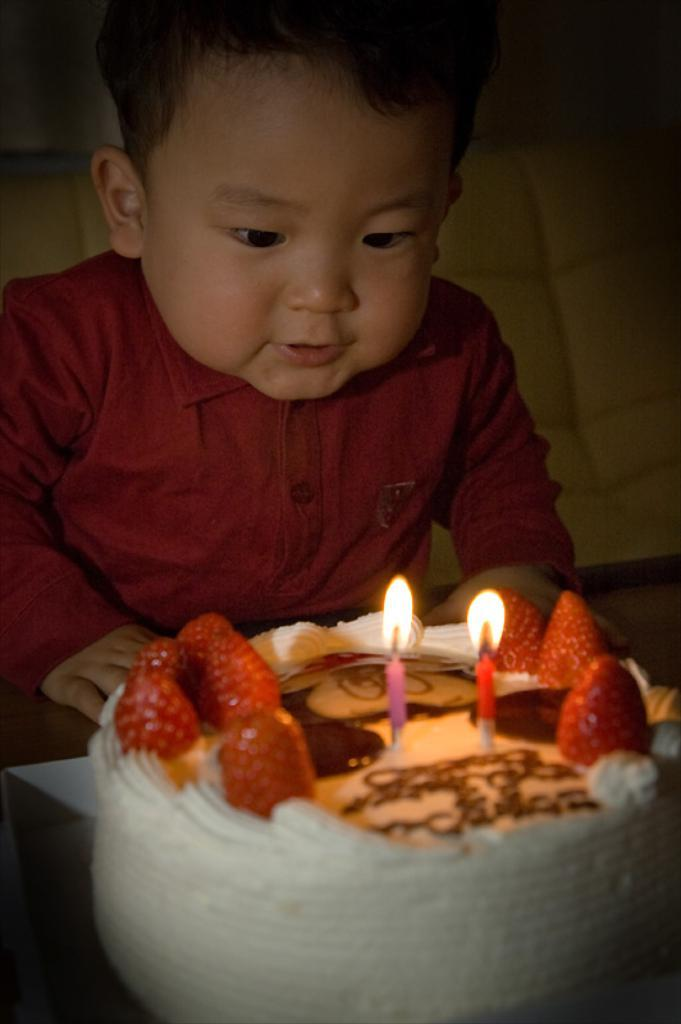What is the main subject of the image? There is a cake in the image. What decorations are on the cake? The cake has strawberries and candles on it. Who is present in the image besides the cake? There is a kid at the top of the image. What is the kid doing in the image? The kid is watching the cake. Can you see a hole in the cake that a banana is being pulled out of? There is no hole or banana present in the image; the cake has strawberries and candles on it. 